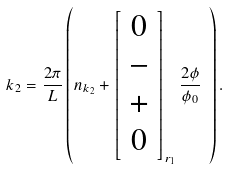<formula> <loc_0><loc_0><loc_500><loc_500>k _ { 2 } = \frac { 2 \pi } { L } \left ( n _ { k _ { 2 } } + \left [ \begin{array} { c } 0 \\ - \\ + \\ 0 \end{array} \right ] _ { r _ { 1 } } \frac { 2 \phi } { \phi _ { 0 } } \ \right ) .</formula> 